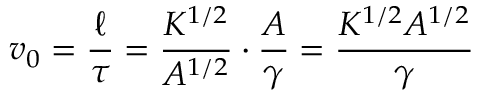<formula> <loc_0><loc_0><loc_500><loc_500>v _ { 0 } = \frac { \ell } { \tau } = \frac { K ^ { 1 / 2 } } { A ^ { 1 / 2 } } \cdot \frac { A } { \gamma } = \frac { K ^ { 1 / 2 } A ^ { 1 / 2 } } { \gamma }</formula> 